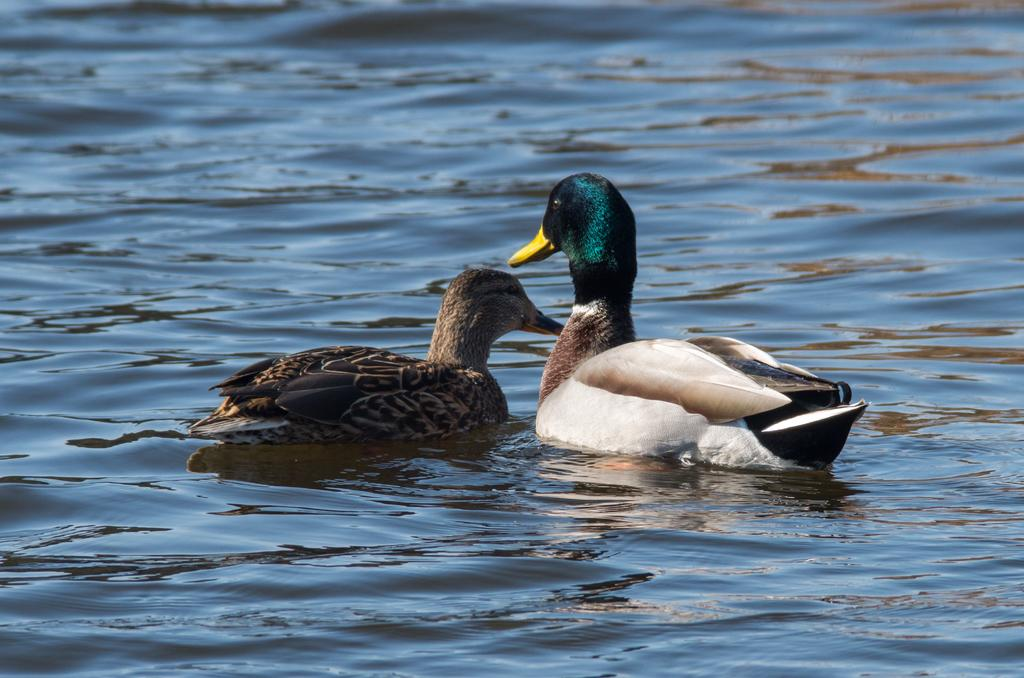What animals are present in the image? There are two ducks in the image. Where are the ducks located? The ducks are on the water. What type of pies can be seen in the image? There are no pies present in the image; it features two ducks on the water. 